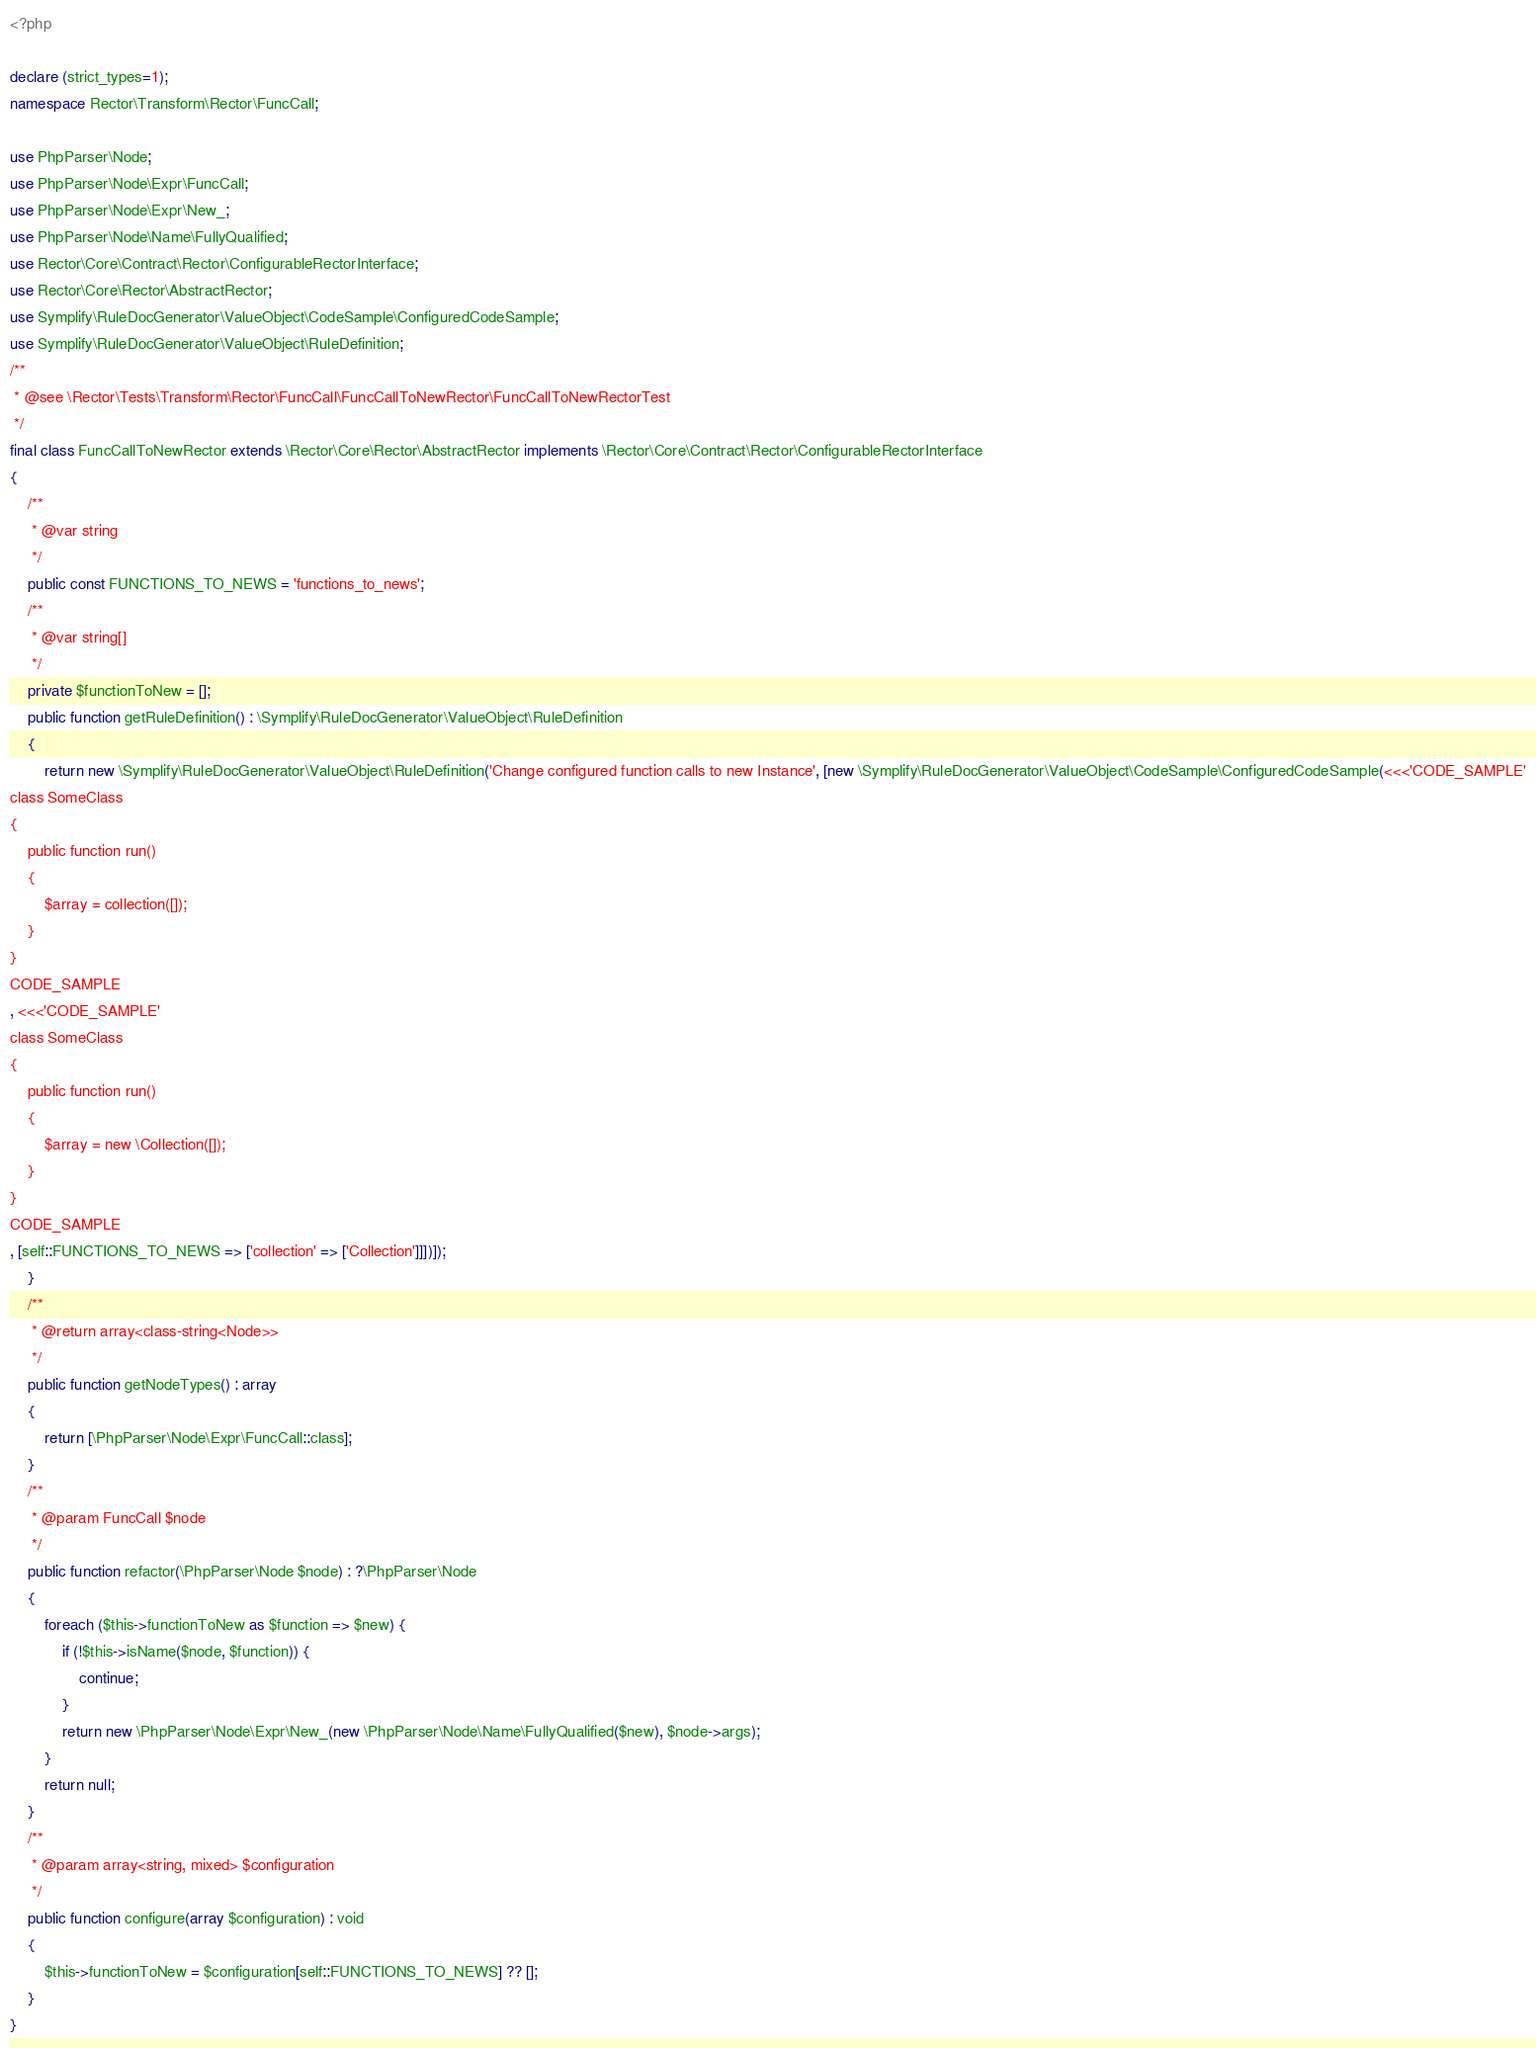Convert code to text. <code><loc_0><loc_0><loc_500><loc_500><_PHP_><?php

declare (strict_types=1);
namespace Rector\Transform\Rector\FuncCall;

use PhpParser\Node;
use PhpParser\Node\Expr\FuncCall;
use PhpParser\Node\Expr\New_;
use PhpParser\Node\Name\FullyQualified;
use Rector\Core\Contract\Rector\ConfigurableRectorInterface;
use Rector\Core\Rector\AbstractRector;
use Symplify\RuleDocGenerator\ValueObject\CodeSample\ConfiguredCodeSample;
use Symplify\RuleDocGenerator\ValueObject\RuleDefinition;
/**
 * @see \Rector\Tests\Transform\Rector\FuncCall\FuncCallToNewRector\FuncCallToNewRectorTest
 */
final class FuncCallToNewRector extends \Rector\Core\Rector\AbstractRector implements \Rector\Core\Contract\Rector\ConfigurableRectorInterface
{
    /**
     * @var string
     */
    public const FUNCTIONS_TO_NEWS = 'functions_to_news';
    /**
     * @var string[]
     */
    private $functionToNew = [];
    public function getRuleDefinition() : \Symplify\RuleDocGenerator\ValueObject\RuleDefinition
    {
        return new \Symplify\RuleDocGenerator\ValueObject\RuleDefinition('Change configured function calls to new Instance', [new \Symplify\RuleDocGenerator\ValueObject\CodeSample\ConfiguredCodeSample(<<<'CODE_SAMPLE'
class SomeClass
{
    public function run()
    {
        $array = collection([]);
    }
}
CODE_SAMPLE
, <<<'CODE_SAMPLE'
class SomeClass
{
    public function run()
    {
        $array = new \Collection([]);
    }
}
CODE_SAMPLE
, [self::FUNCTIONS_TO_NEWS => ['collection' => ['Collection']]])]);
    }
    /**
     * @return array<class-string<Node>>
     */
    public function getNodeTypes() : array
    {
        return [\PhpParser\Node\Expr\FuncCall::class];
    }
    /**
     * @param FuncCall $node
     */
    public function refactor(\PhpParser\Node $node) : ?\PhpParser\Node
    {
        foreach ($this->functionToNew as $function => $new) {
            if (!$this->isName($node, $function)) {
                continue;
            }
            return new \PhpParser\Node\Expr\New_(new \PhpParser\Node\Name\FullyQualified($new), $node->args);
        }
        return null;
    }
    /**
     * @param array<string, mixed> $configuration
     */
    public function configure(array $configuration) : void
    {
        $this->functionToNew = $configuration[self::FUNCTIONS_TO_NEWS] ?? [];
    }
}
</code> 